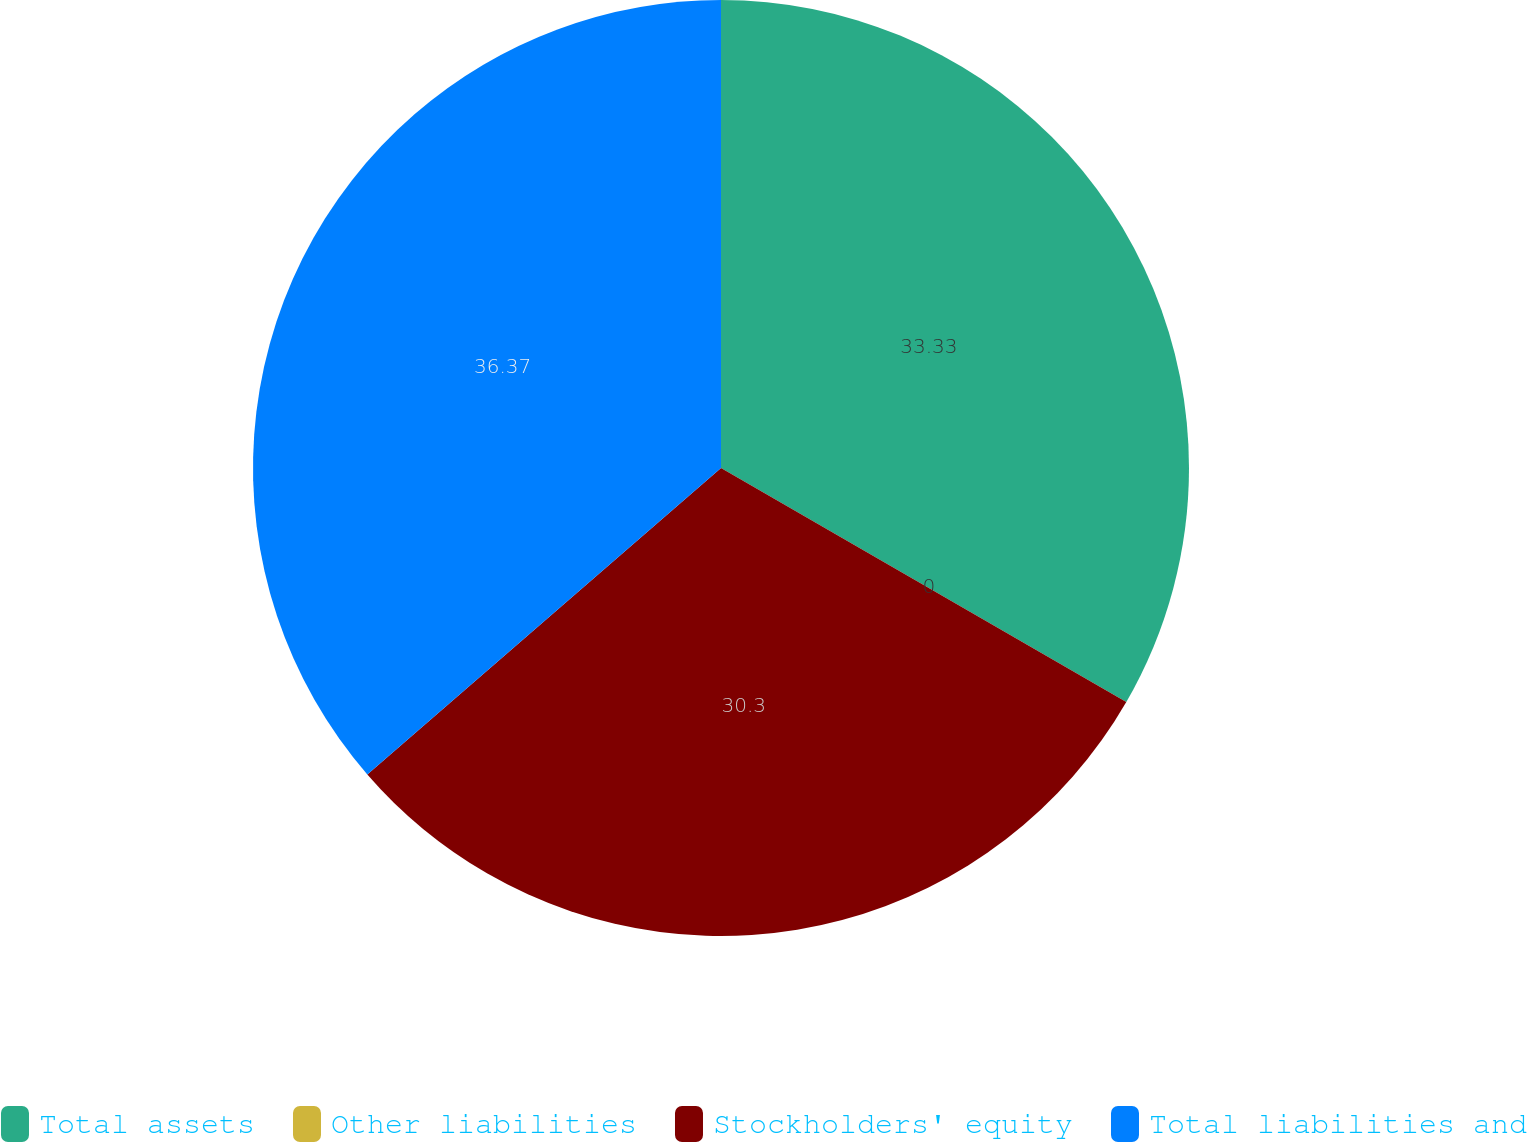Convert chart to OTSL. <chart><loc_0><loc_0><loc_500><loc_500><pie_chart><fcel>Total assets<fcel>Other liabilities<fcel>Stockholders' equity<fcel>Total liabilities and<nl><fcel>33.33%<fcel>0.0%<fcel>30.3%<fcel>36.36%<nl></chart> 